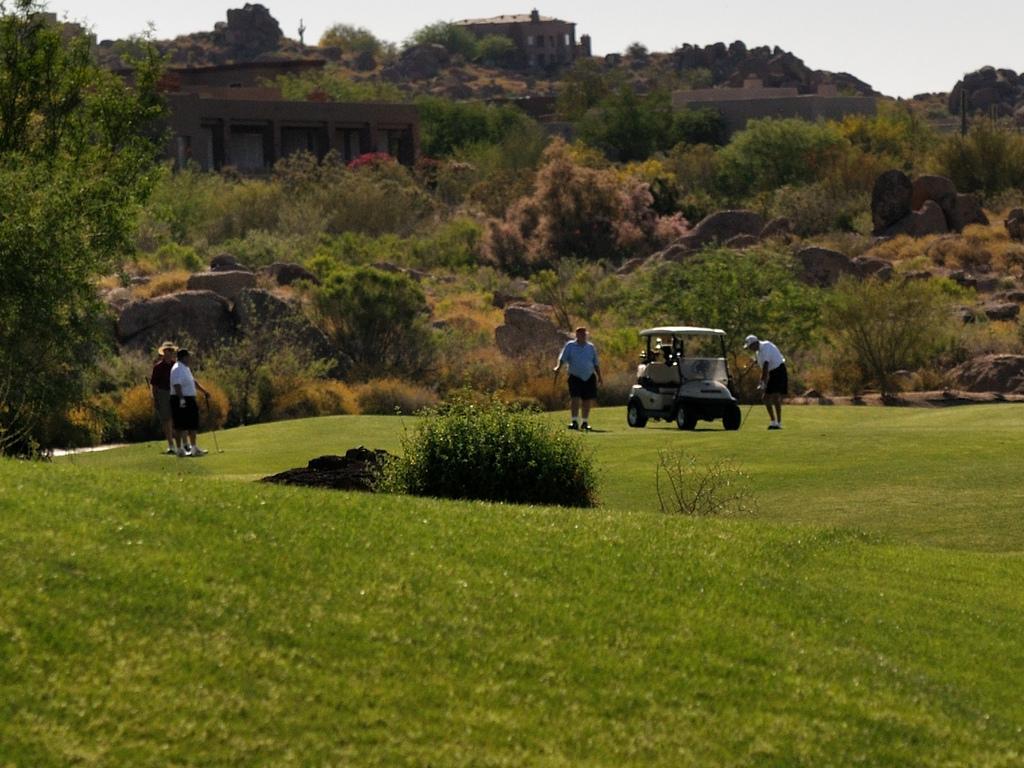Can you describe this image briefly? There is greenery in the foreground, there are people and a vehicle on the grassland in the center. There are trees, stones, building structure and sky in the background area. 